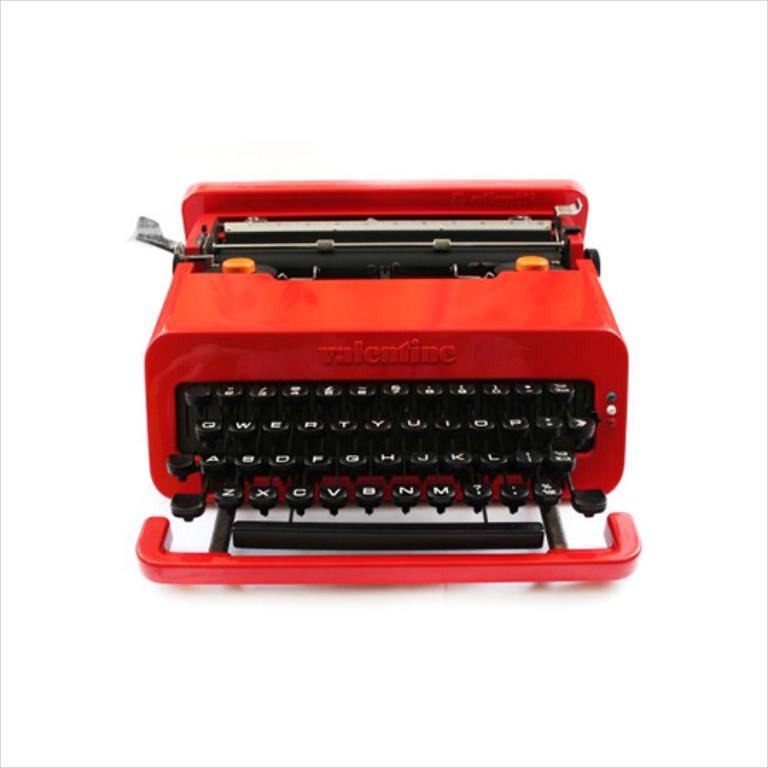Name of this typewriter?
Provide a short and direct response. Valentine. What letters are on the bottom row?
Offer a very short reply. Zxcvbnm. 